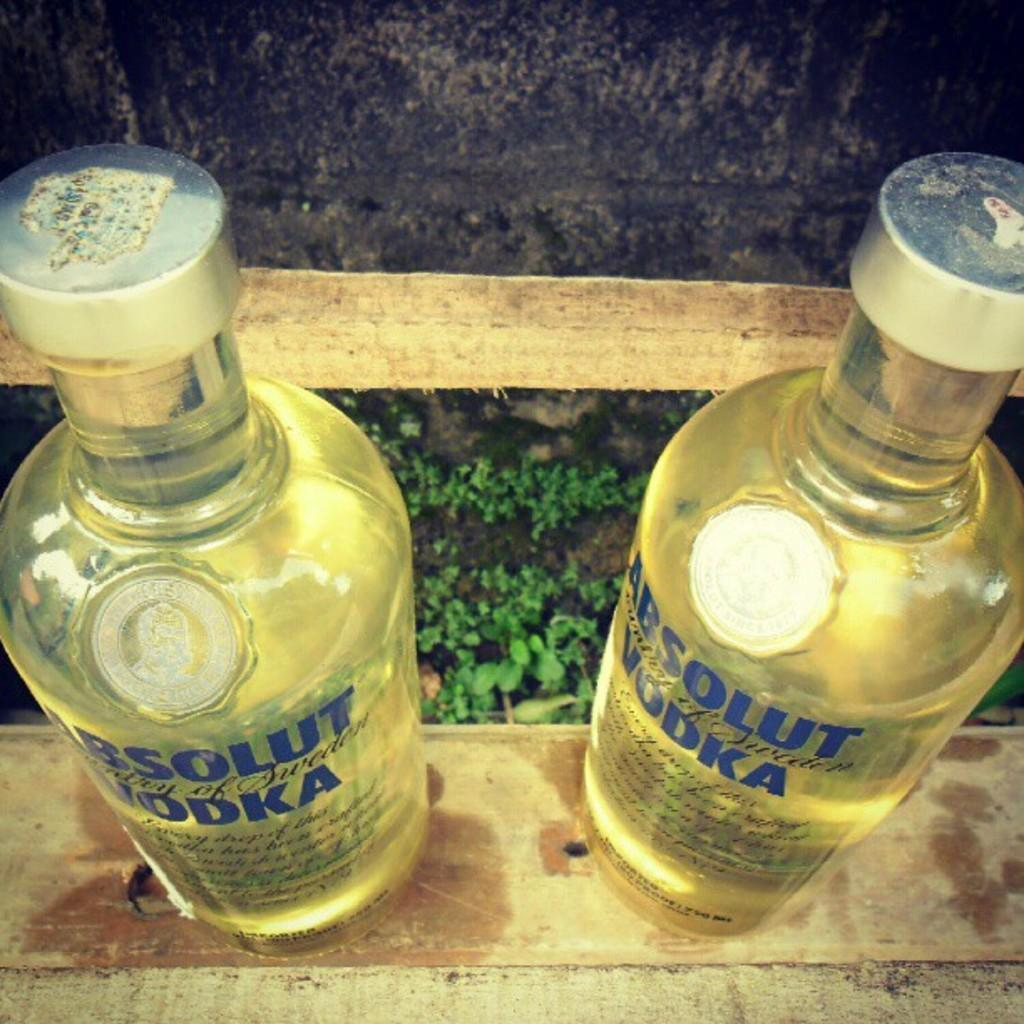<image>
Summarize the visual content of the image. Two vodka bottles are on a wooden table with plants behind them. 